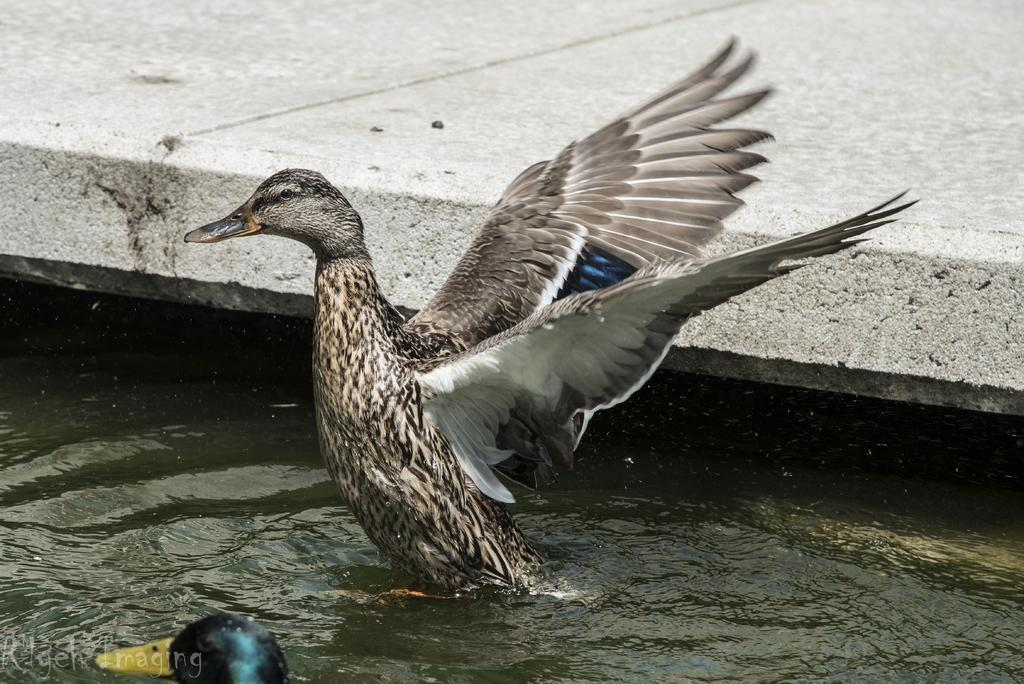What animals are in the water in the image? There are ducks in the water in the image. What type of surface can be seen in the background? There is a concrete slab in the background. Is there any text or marking in the image? Yes, there is a watermark in the left bottom corner of the image. How many girls are playing in the alley in the image? There are no girls or alley present in the image; it features ducks in the water and a concrete slab in the background. 